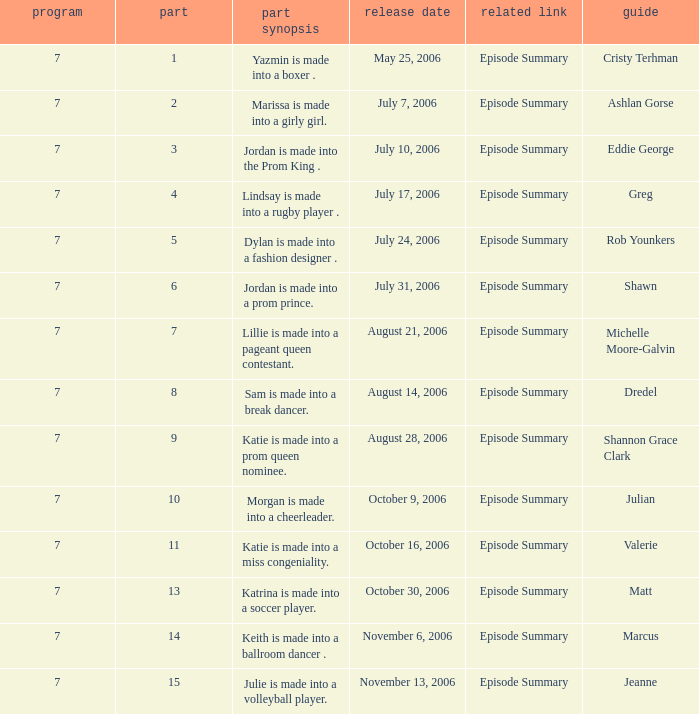How many episodes have Valerie? 1.0. 